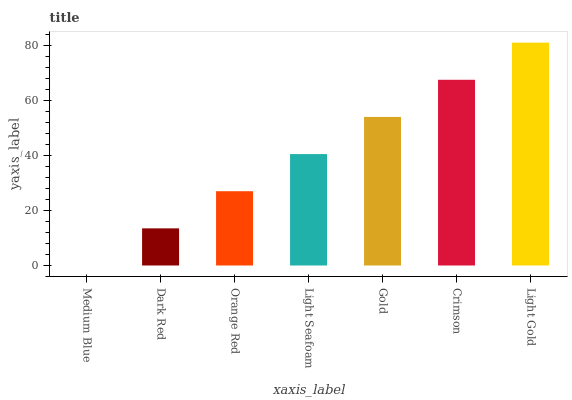Is Medium Blue the minimum?
Answer yes or no. Yes. Is Light Gold the maximum?
Answer yes or no. Yes. Is Dark Red the minimum?
Answer yes or no. No. Is Dark Red the maximum?
Answer yes or no. No. Is Dark Red greater than Medium Blue?
Answer yes or no. Yes. Is Medium Blue less than Dark Red?
Answer yes or no. Yes. Is Medium Blue greater than Dark Red?
Answer yes or no. No. Is Dark Red less than Medium Blue?
Answer yes or no. No. Is Light Seafoam the high median?
Answer yes or no. Yes. Is Light Seafoam the low median?
Answer yes or no. Yes. Is Dark Red the high median?
Answer yes or no. No. Is Light Gold the low median?
Answer yes or no. No. 